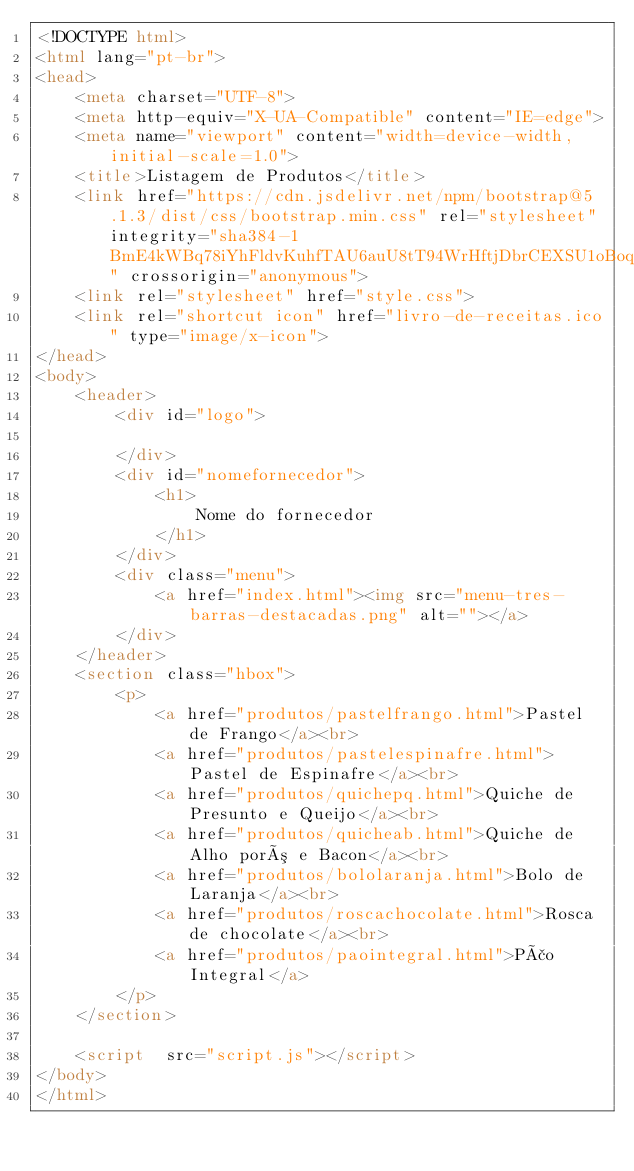<code> <loc_0><loc_0><loc_500><loc_500><_HTML_><!DOCTYPE html>
<html lang="pt-br">
<head>
    <meta charset="UTF-8">
    <meta http-equiv="X-UA-Compatible" content="IE=edge">
    <meta name="viewport" content="width=device-width, initial-scale=1.0">
    <title>Listagem de Produtos</title>
    <link href="https://cdn.jsdelivr.net/npm/bootstrap@5.1.3/dist/css/bootstrap.min.css" rel="stylesheet" integrity="sha384-1BmE4kWBq78iYhFldvKuhfTAU6auU8tT94WrHftjDbrCEXSU1oBoqyl2QvZ6jIW3" crossorigin="anonymous">
    <link rel="stylesheet" href="style.css">
    <link rel="shortcut icon" href="livro-de-receitas.ico" type="image/x-icon">
</head>
<body>
    <header>
        <div id="logo">

        </div>
        <div id="nomefornecedor">
            <h1>
                Nome do fornecedor
            </h1>   
        </div>
        <div class="menu">
            <a href="index.html"><img src="menu-tres-barras-destacadas.png" alt=""></a>
        </div>
    </header>
    <section class="hbox">
        <p>
            <a href="produtos/pastelfrango.html">Pastel de Frango</a><br>
            <a href="produtos/pastelespinafre.html">Pastel de Espinafre</a><br>
            <a href="produtos/quichepq.html">Quiche de Presunto e Queijo</a><br>
            <a href="produtos/quicheab.html">Quiche de Alho poró e Bacon</a><br>
            <a href="produtos/bololaranja.html">Bolo de Laranja</a><br>
            <a href="produtos/roscachocolate.html">Rosca de chocolate</a><br>
            <a href="produtos/paointegral.html">Pão Integral</a>
        </p>
    </section>
    
    <script  src="script.js"></script>
</body>
</html></code> 